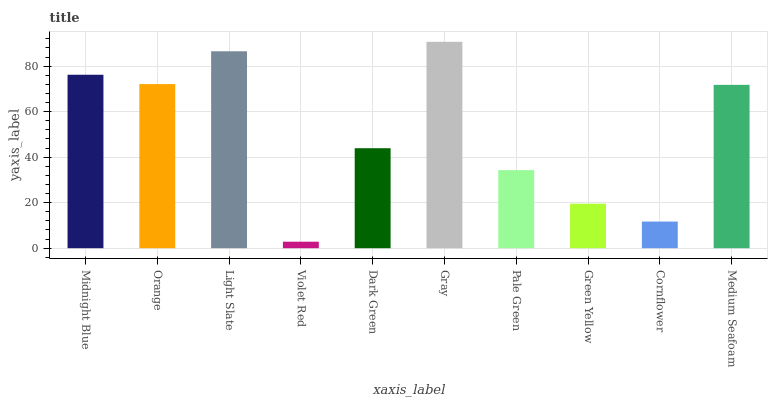Is Violet Red the minimum?
Answer yes or no. Yes. Is Gray the maximum?
Answer yes or no. Yes. Is Orange the minimum?
Answer yes or no. No. Is Orange the maximum?
Answer yes or no. No. Is Midnight Blue greater than Orange?
Answer yes or no. Yes. Is Orange less than Midnight Blue?
Answer yes or no. Yes. Is Orange greater than Midnight Blue?
Answer yes or no. No. Is Midnight Blue less than Orange?
Answer yes or no. No. Is Medium Seafoam the high median?
Answer yes or no. Yes. Is Dark Green the low median?
Answer yes or no. Yes. Is Cornflower the high median?
Answer yes or no. No. Is Pale Green the low median?
Answer yes or no. No. 